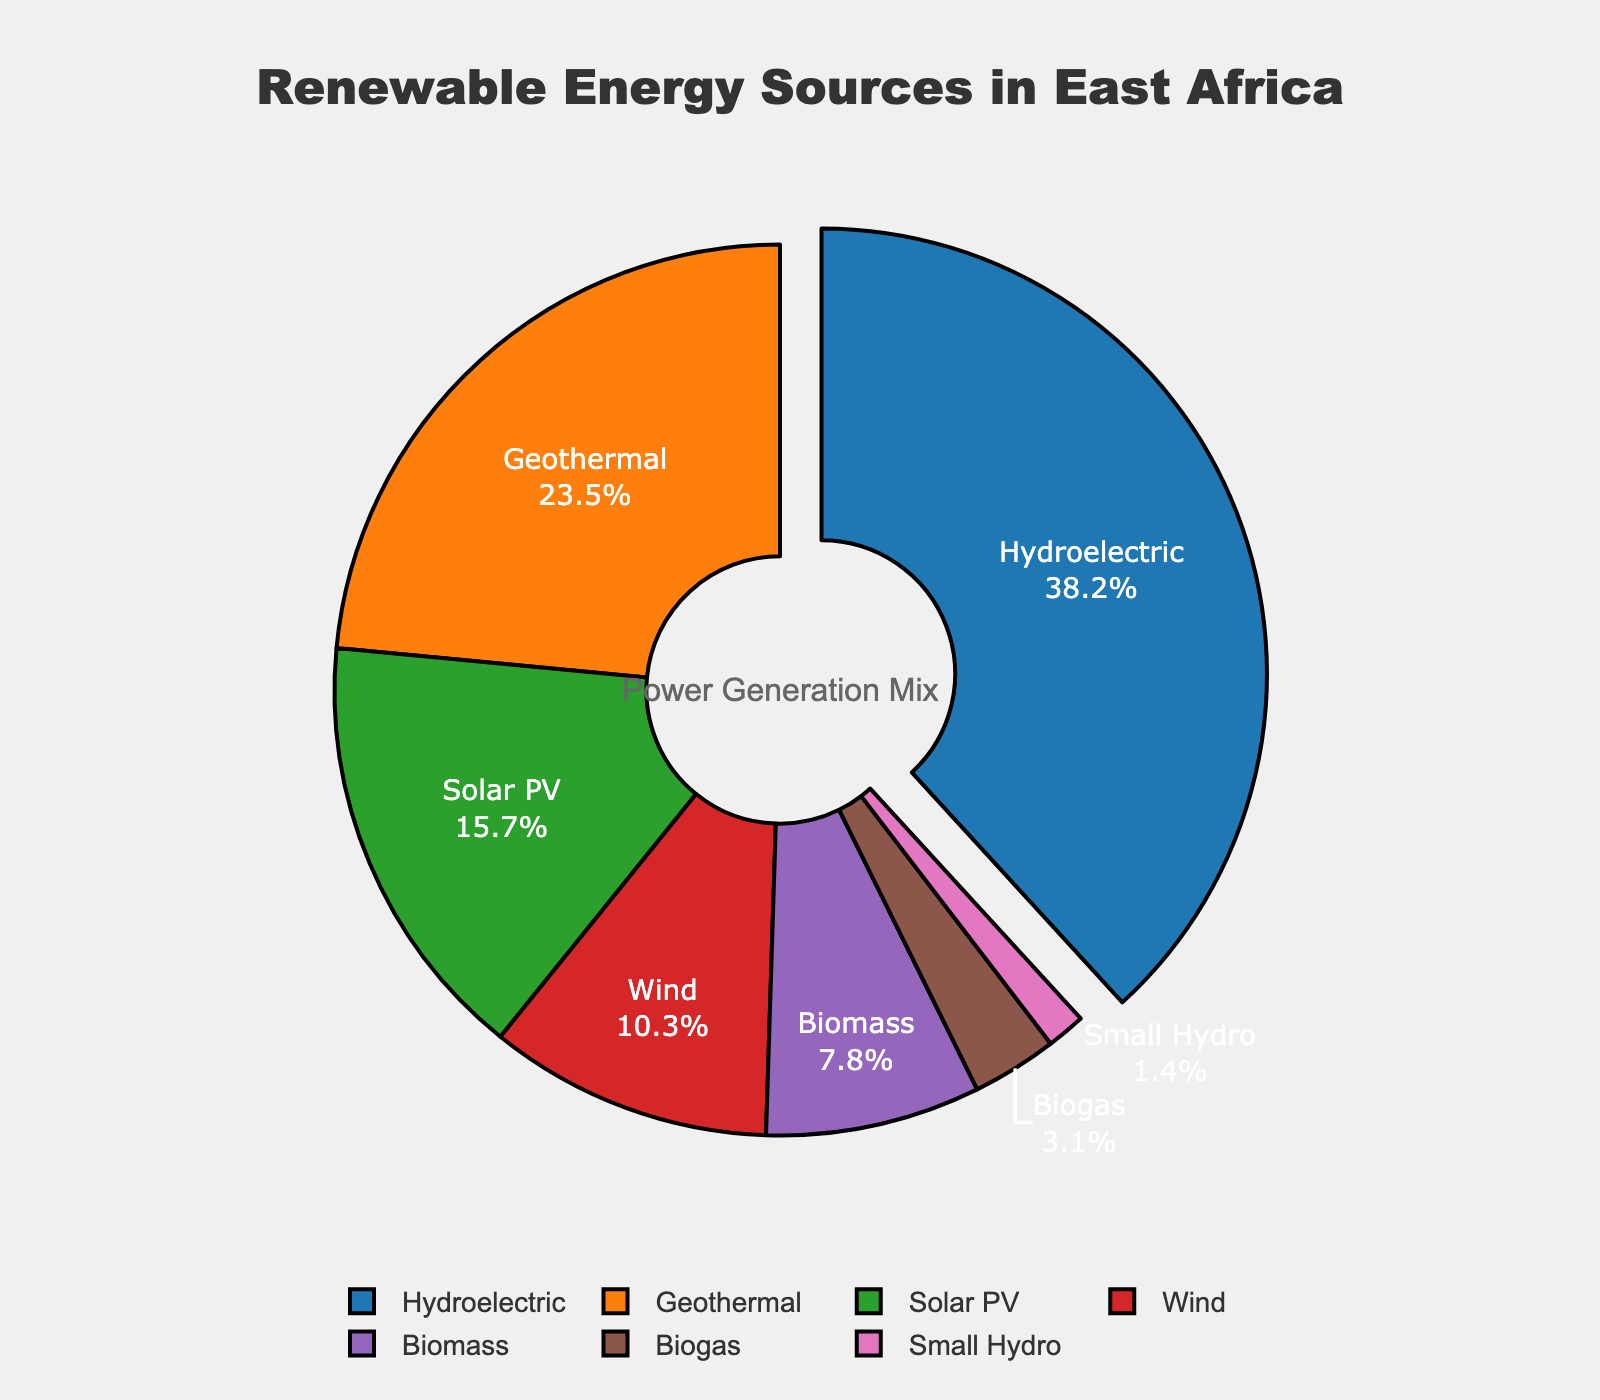Which renewable energy source represents the largest portion in the pie chart? The pie chart labels both the energy sources and their respective percentages. Hydroelectric is labeled with the largest percentage at 38.2%, making it the largest portion.
Answer: Hydroelectric What is the combined percentage for Solar PV and Wind? To find the combined percentage, add the percentages of Solar PV (15.7%) and Wind (10.3%). 15.7 + 10.3 = 26.
Answer: 26 How does the percentage of Geothermal compare to Biomass? Comparing the two percentages: Geothermal (23.5%) and Biomass (7.8%), Geothermal is significantly higher.
Answer: Geothermal is higher Which energy source pulls out from the pie chart, and why? The energy source that pulls out is the largest section of the pie chart. In this case, Hydroelectric has the highest percentage at 38.2%, so it pulls out.
Answer: Hydroelectric What is the difference in percentage between Biogas and Small Hydro? To find the difference, subtract the percentage of Small Hydro (1.4%) from Biogas (3.1%). 3.1 - 1.4 = 1.7.
Answer: 1.7 Which two renewable energy sources combined make up less than 10% of the power generation mix? Adding the percentages of Biogas (3.1%) and Small Hydro (1.4%) gives us 3.1 + 1.4 = 4.5, which is less than 10%.
Answer: Biogas and Small Hydro How much more is the percentage of Hydroelectric compared to the least prevalent source? The least prevalent source is Small Hydro at 1.4%. Subtracting this from Hydroelectric (38.2%), we get 38.2 - 1.4 = 36.8.
Answer: 36.8 What is the average percentage of Geothermal, Solar PV, and Wind? To find the average percentage, add the percentages of Geothermal (23.5%), Solar PV (15.7%), and Wind (10.3%), then divide by the number of sources. (23.5 + 15.7 + 10.3) / 3 = 49.5 / 3 = 16.5.
Answer: 16.5 Which portion is represented in red in the pie chart? Observing the color legend in the pie chart: the red portion corresponds to Wind, as indicated by its color and label.
Answer: Wind 